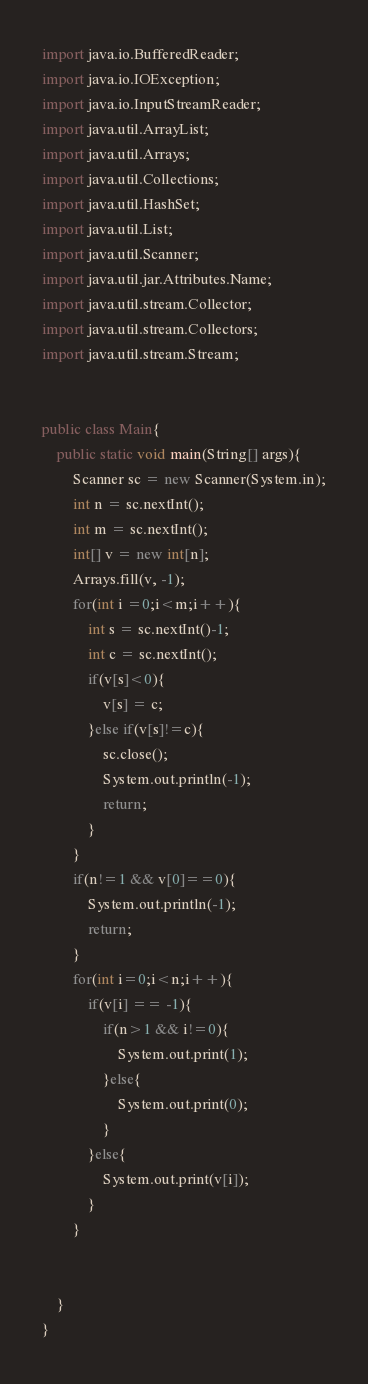<code> <loc_0><loc_0><loc_500><loc_500><_Java_>import java.io.BufferedReader;
import java.io.IOException;
import java.io.InputStreamReader;
import java.util.ArrayList;
import java.util.Arrays;
import java.util.Collections;
import java.util.HashSet;
import java.util.List;
import java.util.Scanner;
import java.util.jar.Attributes.Name;
import java.util.stream.Collector;
import java.util.stream.Collectors;
import java.util.stream.Stream;


public class Main{
    public static void main(String[] args){
        Scanner sc = new Scanner(System.in);
        int n = sc.nextInt(); 
        int m = sc.nextInt();
        int[] v = new int[n];
        Arrays.fill(v, -1);
        for(int i =0;i<m;i++){
            int s = sc.nextInt()-1;
            int c = sc.nextInt();
            if(v[s]<0){
                v[s] = c;
            }else if(v[s]!=c){
                sc.close();
                System.out.println(-1);
                return;
            }
        }
        if(n!=1 && v[0]==0){
            System.out.println(-1); 
            return;  
        }
        for(int i=0;i<n;i++){
            if(v[i] == -1){
                if(n>1 && i!=0){
                    System.out.print(1);
                }else{
                    System.out.print(0);
                }
            }else{
                System.out.print(v[i]);
            }
        }

        
    }
}

</code> 